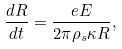<formula> <loc_0><loc_0><loc_500><loc_500>\frac { d R } { d t } = \frac { e E } { 2 \pi \rho _ { s } \kappa R } ,</formula> 